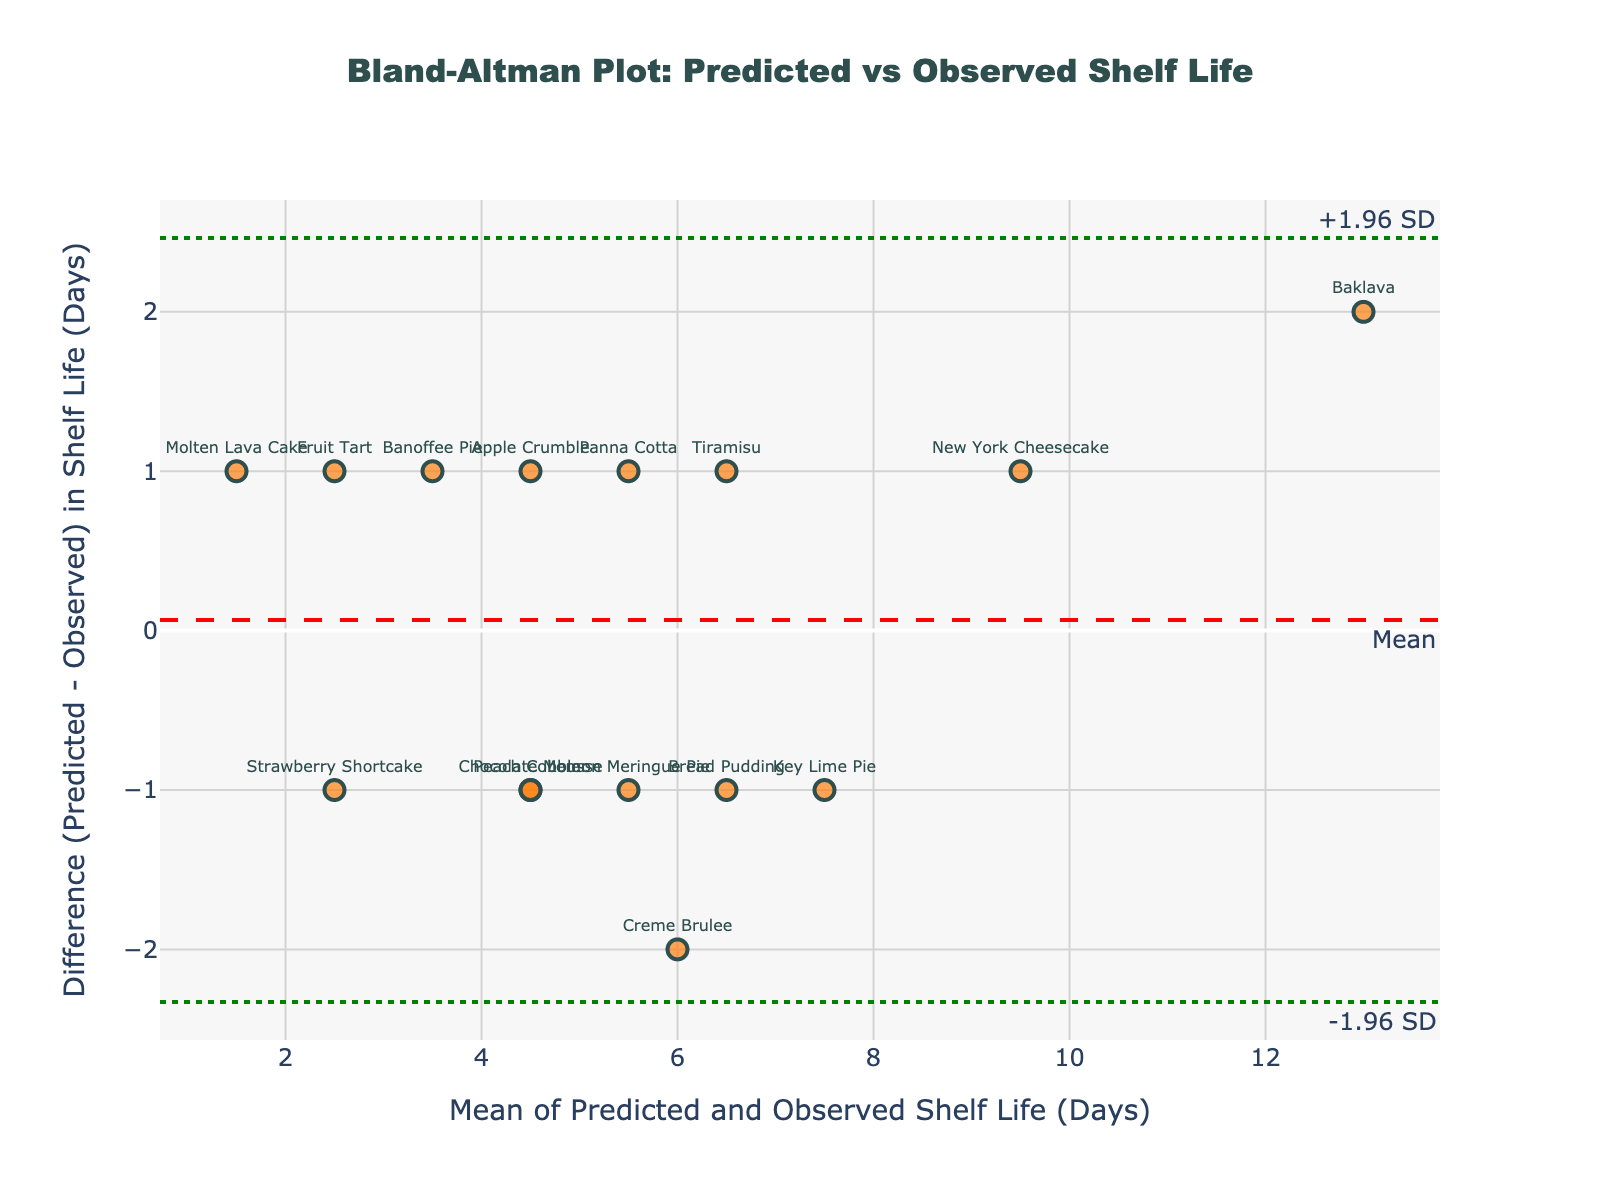What's the title of the plot? The title is usually displayed at the top of the plot. It provides a summary of what the plot represents. In this case, the title is shown at the top center of the figure.
Answer: Bland-Altman Plot: Predicted vs Observed Shelf Life What's the y-axis label? The y-axis label is displayed vertically on the left side of the plot, and it indicates what is being measured along the y-axis. Here, it refers to the difference in days between predicted and observed shelf life.
Answer: Difference (Predicted - Observed) in Shelf Life (Days) Which dessert has the largest positive difference between predicted and observed shelf life? To identify this, look at the data points and labels on the graph to find the one with the highest value along the y-axis. This is the point farthest above the zero line.
Answer: Creme Brulee What is the mean difference between predicted and observed shelf life? The mean difference is represented by the dashed red horizontal line on the plot. The value is annotated near this line.
Answer: 0.2 What are the limits of agreement for the differences? The limits of agreement are represented by the dotted green horizontal lines. These values are annotated near the respective lines.
Answer: -2.16 and 2.56 Which dessert product has an observed shelf life of 8 days and a predicted shelf life of 7 days? Find the label on the plot at the point where the mean (along the x-axis) is 7.5 days and the difference (along the y-axis) is -1 day.
Answer: Key Lime Pie Is the mean difference above or below zero? The mean difference is shown by the dashed red line. If it's above the zero line, the mean difference is positive; if below, it's negative.
Answer: Above How many desserts have a negative difference between predicted and observed shelf life? Count all the data points below the zero line on the y-axis.
Answer: 8 Which dessert has the closest predicted and observed shelf life? Look for the data point closest to the y-axis value of 0, meaning the difference is minimal.
Answer: New York Cheesecake Are there more data points above or below the mean difference line? Visually count the number of data points above and below the dashed red line that represents the mean difference.
Answer: Below 